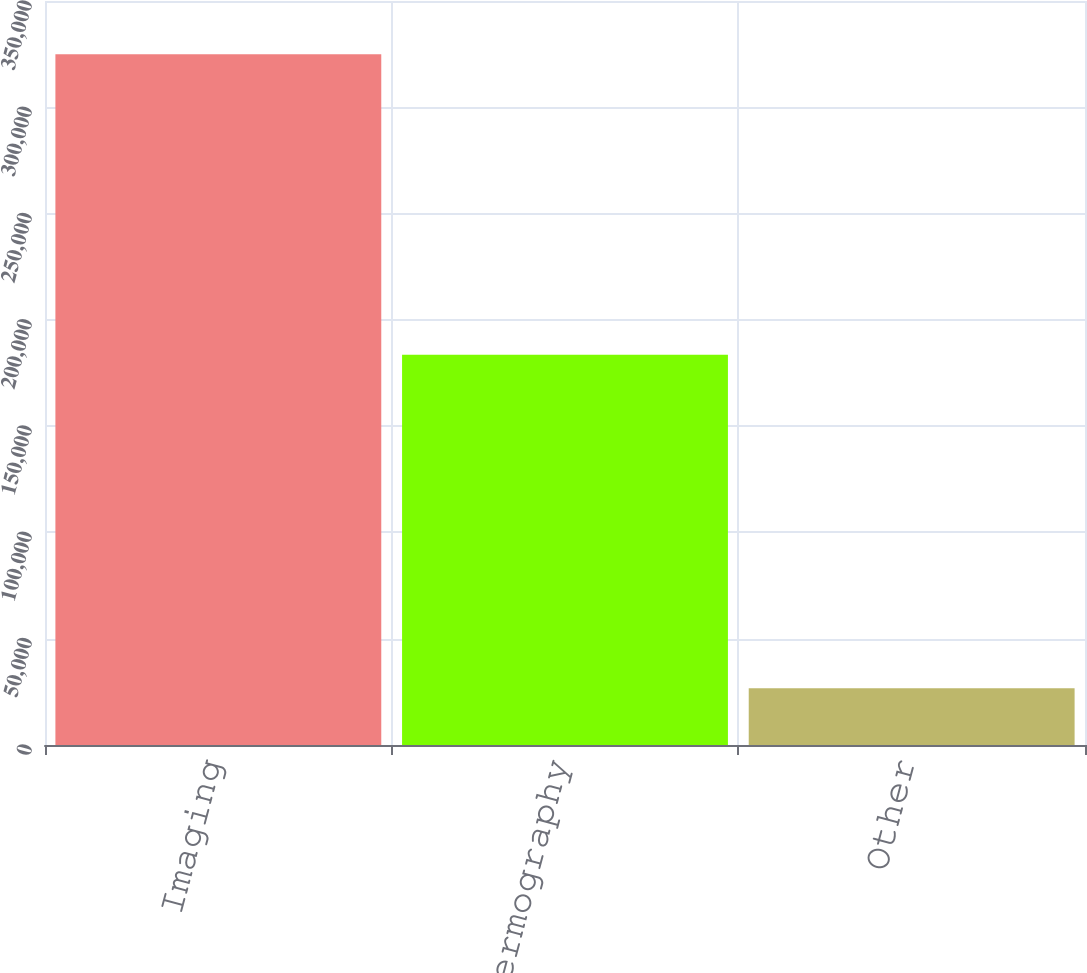Convert chart. <chart><loc_0><loc_0><loc_500><loc_500><bar_chart><fcel>Imaging<fcel>Thermography<fcel>Other<nl><fcel>324955<fcel>183606<fcel>26645<nl></chart> 